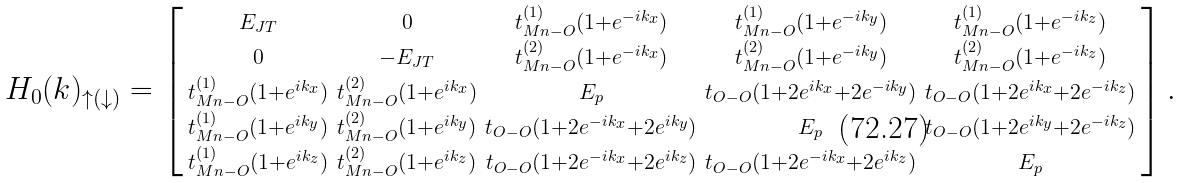<formula> <loc_0><loc_0><loc_500><loc_500>H _ { 0 } ( { k } ) _ { \uparrow ( \downarrow ) } = \left [ \begin{smallmatrix} E _ { J T } & 0 & t _ { M n - O } ^ { ( 1 ) } ( 1 + e ^ { - i k _ { x } } ) & t _ { M n - O } ^ { ( 1 ) } ( 1 + e ^ { - i k _ { y } } ) & t _ { M n - O } ^ { ( 1 ) } ( 1 + e ^ { - i k _ { z } } ) \\ 0 & - E _ { J T } & t _ { M n - O } ^ { ( 2 ) } ( 1 + e ^ { - i k _ { x } } ) & t _ { M n - O } ^ { ( 2 ) } ( 1 + e ^ { - i k _ { y } } ) & t _ { M n - O } ^ { ( 2 ) } ( 1 + e ^ { - i k _ { z } } ) \\ t _ { M n - O } ^ { ( 1 ) } ( 1 + e ^ { i k _ { x } } ) & t _ { M n - O } ^ { ( 2 ) } ( 1 + e ^ { i k _ { x } } ) & E _ { p } & t _ { O - O } ( 1 + 2 e ^ { i k _ { x } } + 2 e ^ { - i k _ { y } } ) & t _ { O - O } ( 1 + 2 e ^ { i k _ { x } } + 2 e ^ { - i k _ { z } } ) \\ t _ { M n - O } ^ { ( 1 ) } ( 1 + e ^ { i k _ { y } } ) & t _ { M n - O } ^ { ( 2 ) } ( 1 + e ^ { i k _ { y } } ) & t _ { O - O } ( 1 + 2 e ^ { - i k _ { x } } + 2 e ^ { i k _ { y } } ) & E _ { p } & t _ { O - O } ( 1 + 2 e ^ { i k _ { y } } + 2 e ^ { - i k _ { z } } ) \\ t _ { M n - O } ^ { ( 1 ) } ( 1 + e ^ { i k _ { z } } ) & t _ { M n - O } ^ { ( 2 ) } ( 1 + e ^ { i k _ { z } } ) & t _ { O - O } ( 1 + 2 e ^ { - i k _ { x } } + 2 e ^ { i k _ { z } } ) & t _ { O - O } ( 1 + 2 e ^ { - i k _ { x } } + 2 e ^ { i k _ { z } } ) & E _ { p } \end{smallmatrix} \right ] .</formula> 